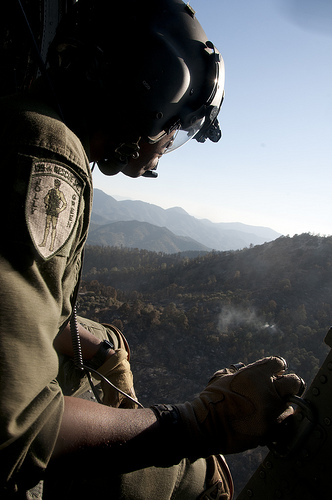<image>
Is there a giant on the sleeve? Yes. Looking at the image, I can see the giant is positioned on top of the sleeve, with the sleeve providing support. 